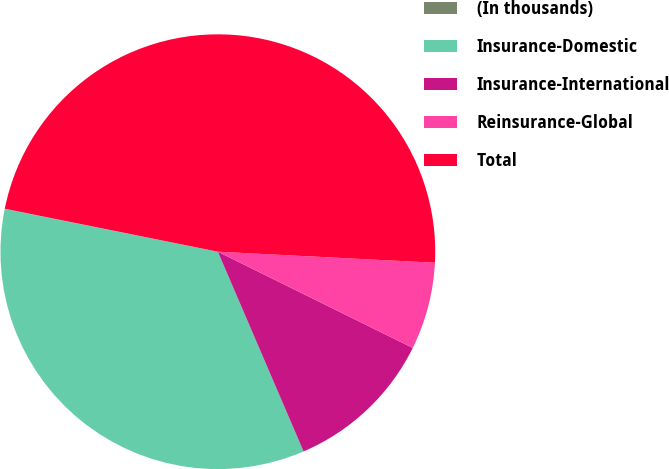Convert chart. <chart><loc_0><loc_0><loc_500><loc_500><pie_chart><fcel>(In thousands)<fcel>Insurance-Domestic<fcel>Insurance-International<fcel>Reinsurance-Global<fcel>Total<nl><fcel>0.02%<fcel>34.6%<fcel>11.25%<fcel>6.49%<fcel>47.64%<nl></chart> 